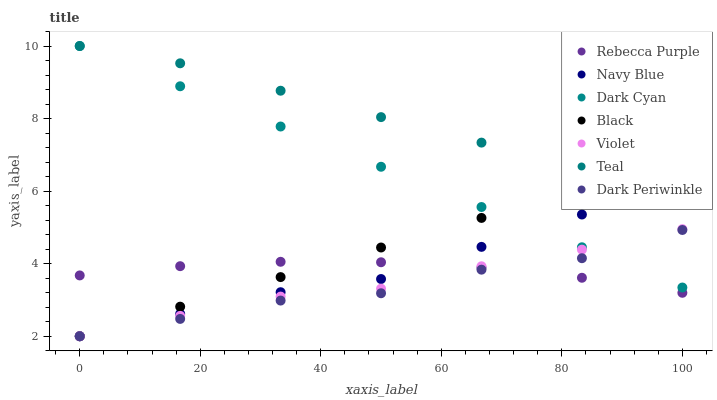Does Dark Periwinkle have the minimum area under the curve?
Answer yes or no. Yes. Does Teal have the maximum area under the curve?
Answer yes or no. Yes. Does Black have the minimum area under the curve?
Answer yes or no. No. Does Black have the maximum area under the curve?
Answer yes or no. No. Is Black the smoothest?
Answer yes or no. Yes. Is Dark Periwinkle the roughest?
Answer yes or no. Yes. Is Rebecca Purple the smoothest?
Answer yes or no. No. Is Rebecca Purple the roughest?
Answer yes or no. No. Does Navy Blue have the lowest value?
Answer yes or no. Yes. Does Rebecca Purple have the lowest value?
Answer yes or no. No. Does Dark Cyan have the highest value?
Answer yes or no. Yes. Does Black have the highest value?
Answer yes or no. No. Is Violet less than Teal?
Answer yes or no. Yes. Is Teal greater than Dark Periwinkle?
Answer yes or no. Yes. Does Navy Blue intersect Black?
Answer yes or no. Yes. Is Navy Blue less than Black?
Answer yes or no. No. Is Navy Blue greater than Black?
Answer yes or no. No. Does Violet intersect Teal?
Answer yes or no. No. 